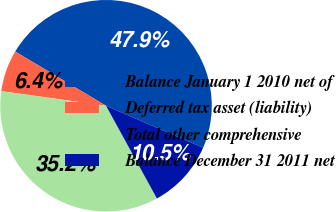Convert chart to OTSL. <chart><loc_0><loc_0><loc_500><loc_500><pie_chart><fcel>Balance January 1 2010 net of<fcel>Deferred tax asset (liability)<fcel>Total other comprehensive<fcel>Balance December 31 2011 net<nl><fcel>47.92%<fcel>6.36%<fcel>35.19%<fcel>10.52%<nl></chart> 